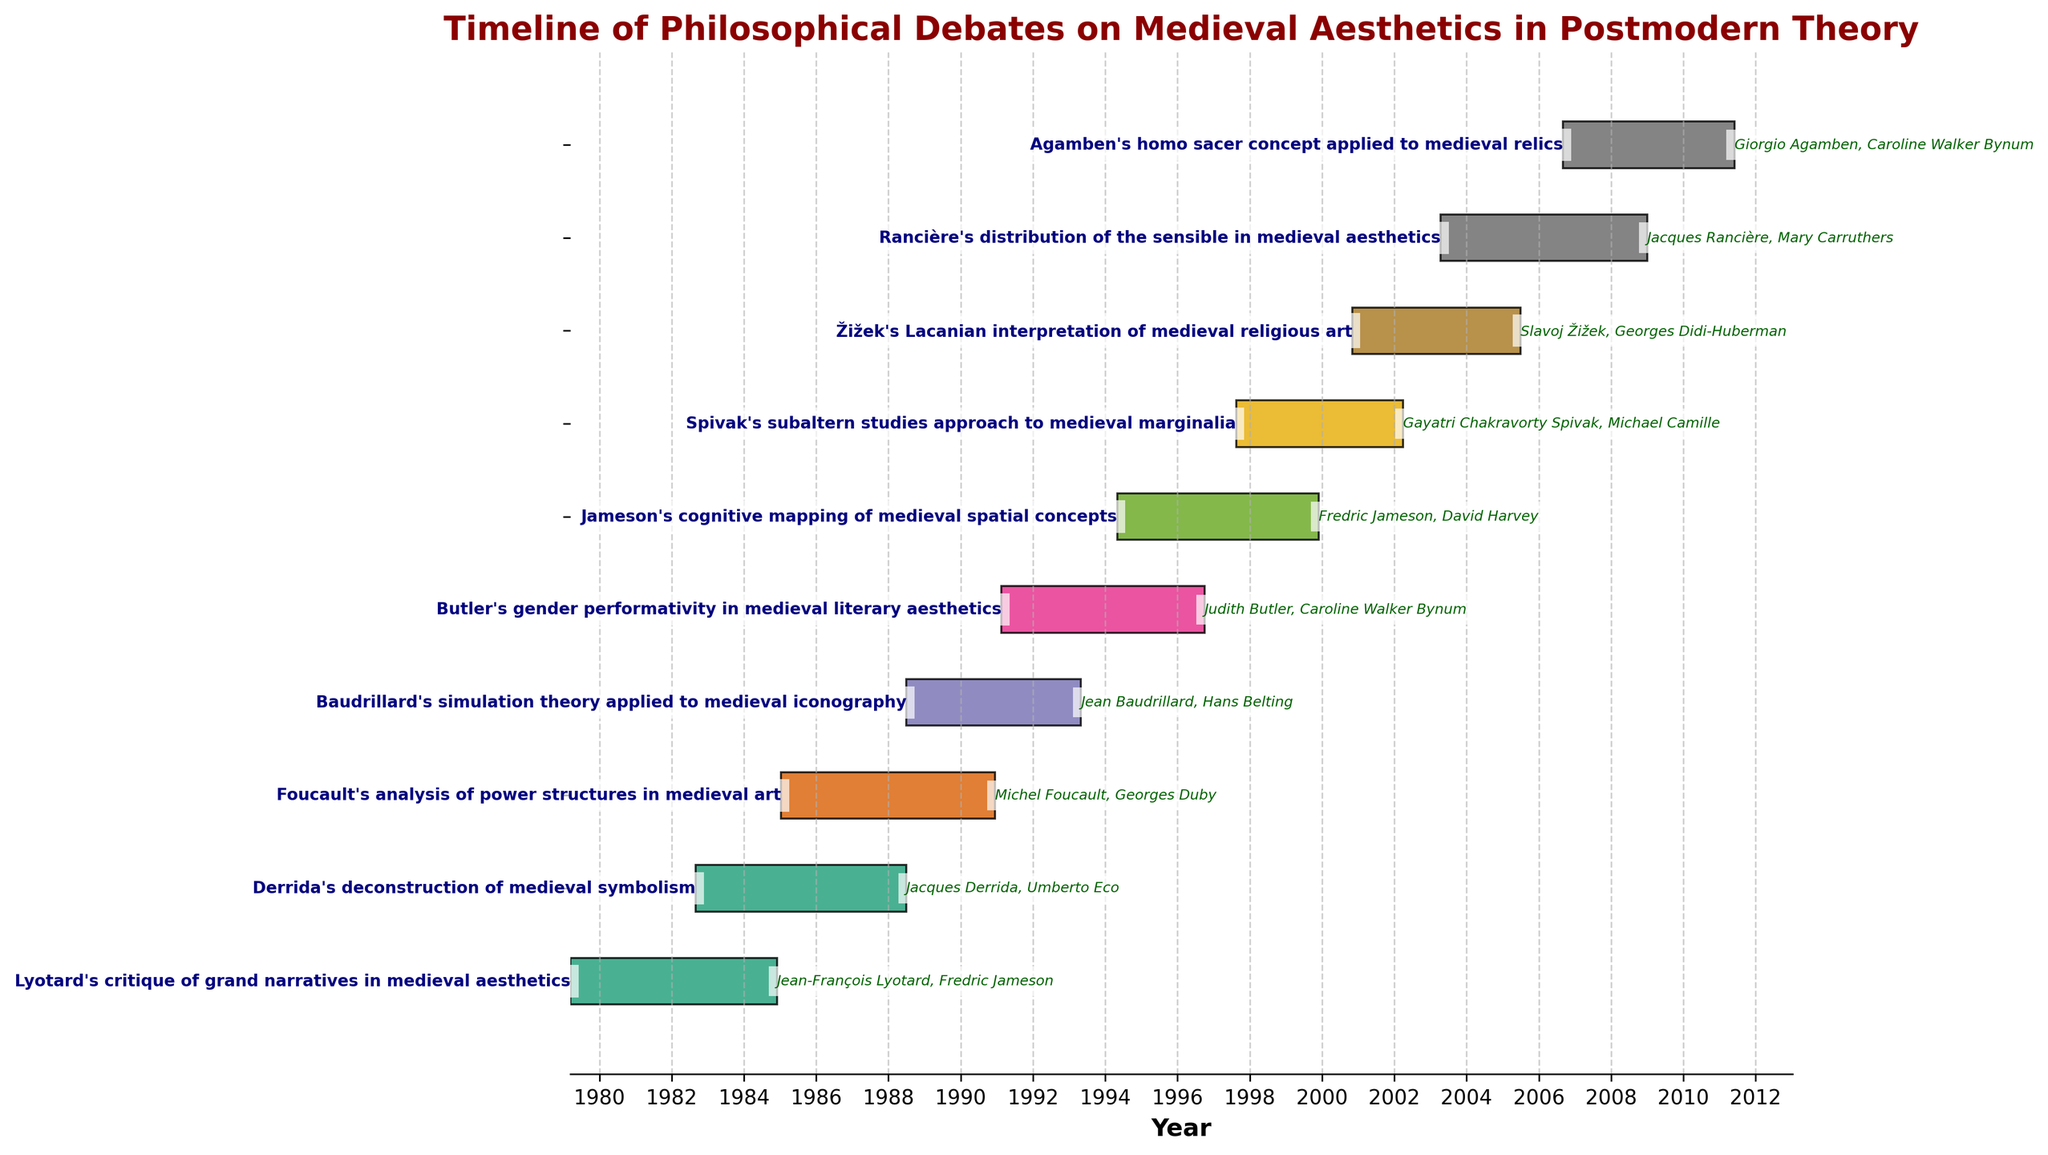How many tasks are depicted in the Gantt chart? Count the number of horizontal bars in the chart. Each bar represents a task.
Answer: 10 What is the title of the Gantt chart? Read the text at the top of the chart, which indicates its purpose or main topic.
Answer: Timeline of Philosophical Debates on Medieval Aesthetics in Postmodern Theory When did Lyotard's critique of grand narratives in medieval aesthetics begin and end? Find the bar labeled "Lyotard's critique of grand narratives in medieval aesthetics." Check the starting and ending dates attached to this bar.
Answer: 1979-03-15 to 1984-11-30 Who were the participants in Derrida's deconstruction of medieval symbolism? Find the bar labeled "Derrida's deconstruction of medieval symbolism." The participants' names are displayed next to this bar.
Answer: Jacques Derrida; Umberto Eco Which task has the longest duration? Compare the lengths of all horizontal bars to determine which extends the farthest horizontally.
Answer: Foucault's analysis of power structures in medieval art Which task started the latest? Look for the bar with the most rightmost starting date along the time axis.
Answer: Agamben's homo sacer concept applied to medieval relics How many years did Butler's analysis span? Identify the start and end dates for "Butler's gender performativity in medieval literary aesthetics." Calculate the difference between the end year and the start year.
Answer: 5 years (1991 to 1996) Which tasks overlapped significantly in terms of their timeline? Identify bars that overlap or significantly coincide along the time axis.
Answer: Derrida's deconstruction of medieval symbolism and Baudrillard's simulation theory applied to medieval iconography Who participated in two debates according to this chart? Scan the participant lists for each task and find any name that appears more than once.
Answer: Fredric Jameson and Caroline Walker Bynum What time period does the Gantt chart cover? Determine the earliest start date and the latest end date among all the tasks depicted.
Answer: 1979-03-15 to 2011-05-31 